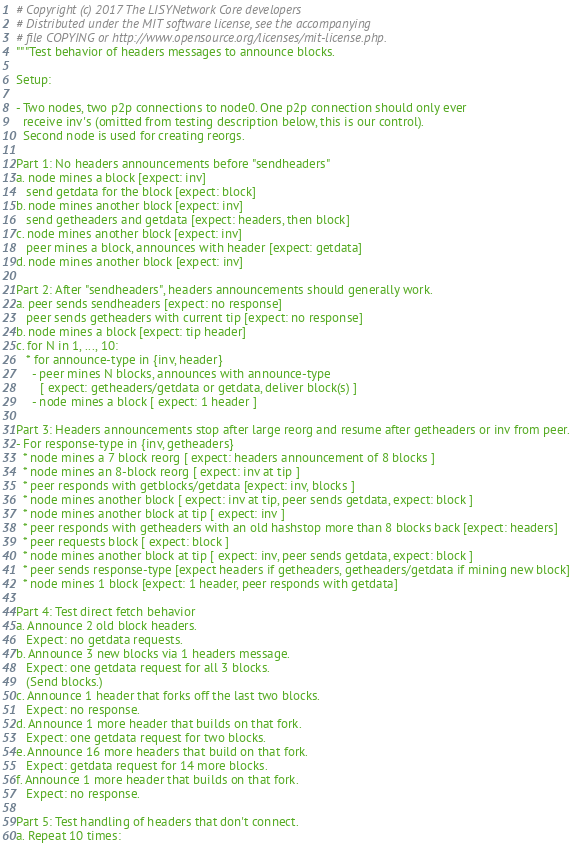Convert code to text. <code><loc_0><loc_0><loc_500><loc_500><_Python_># Copyright (c) 2017 The LISYNetwork Core developers
# Distributed under the MIT software license, see the accompanying
# file COPYING or http://www.opensource.org/licenses/mit-license.php.
"""Test behavior of headers messages to announce blocks.

Setup: 

- Two nodes, two p2p connections to node0. One p2p connection should only ever
  receive inv's (omitted from testing description below, this is our control).
  Second node is used for creating reorgs.

Part 1: No headers announcements before "sendheaders"
a. node mines a block [expect: inv]
   send getdata for the block [expect: block]
b. node mines another block [expect: inv]
   send getheaders and getdata [expect: headers, then block]
c. node mines another block [expect: inv]
   peer mines a block, announces with header [expect: getdata]
d. node mines another block [expect: inv]

Part 2: After "sendheaders", headers announcements should generally work.
a. peer sends sendheaders [expect: no response]
   peer sends getheaders with current tip [expect: no response]
b. node mines a block [expect: tip header]
c. for N in 1, ..., 10:
   * for announce-type in {inv, header}
     - peer mines N blocks, announces with announce-type
       [ expect: getheaders/getdata or getdata, deliver block(s) ]
     - node mines a block [ expect: 1 header ]

Part 3: Headers announcements stop after large reorg and resume after getheaders or inv from peer.
- For response-type in {inv, getheaders}
  * node mines a 7 block reorg [ expect: headers announcement of 8 blocks ]
  * node mines an 8-block reorg [ expect: inv at tip ]
  * peer responds with getblocks/getdata [expect: inv, blocks ]
  * node mines another block [ expect: inv at tip, peer sends getdata, expect: block ]
  * node mines another block at tip [ expect: inv ]
  * peer responds with getheaders with an old hashstop more than 8 blocks back [expect: headers]
  * peer requests block [ expect: block ]
  * node mines another block at tip [ expect: inv, peer sends getdata, expect: block ]
  * peer sends response-type [expect headers if getheaders, getheaders/getdata if mining new block]
  * node mines 1 block [expect: 1 header, peer responds with getdata]

Part 4: Test direct fetch behavior
a. Announce 2 old block headers.
   Expect: no getdata requests.
b. Announce 3 new blocks via 1 headers message.
   Expect: one getdata request for all 3 blocks.
   (Send blocks.)
c. Announce 1 header that forks off the last two blocks.
   Expect: no response.
d. Announce 1 more header that builds on that fork.
   Expect: one getdata request for two blocks.
e. Announce 16 more headers that build on that fork.
   Expect: getdata request for 14 more blocks.
f. Announce 1 more header that builds on that fork.
   Expect: no response.

Part 5: Test handling of headers that don't connect.
a. Repeat 10 times:</code> 